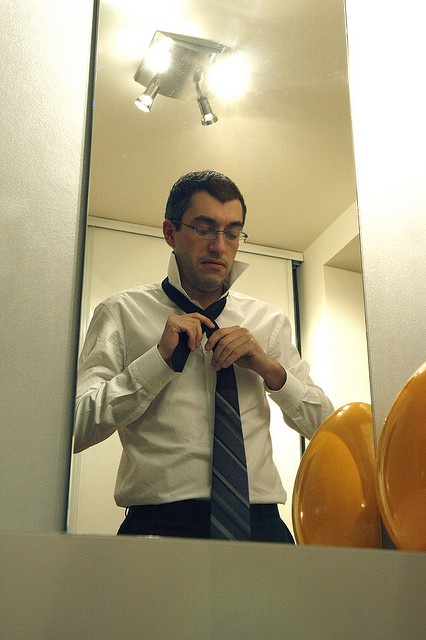Describe the objects in this image and their specific colors. I can see people in beige, black, tan, and gray tones, vase in beige, brown, maroon, and tan tones, and tie in beige, black, and gray tones in this image. 